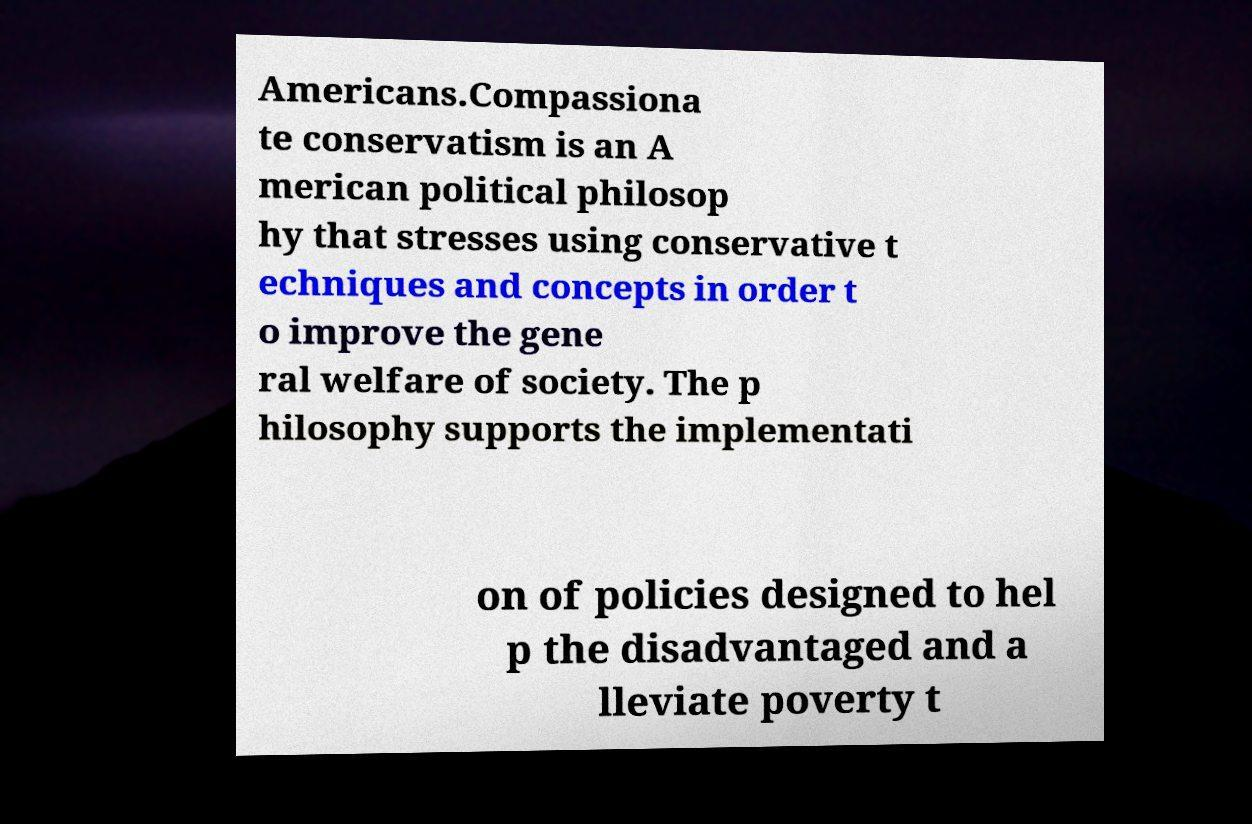For documentation purposes, I need the text within this image transcribed. Could you provide that? Americans.Compassiona te conservatism is an A merican political philosop hy that stresses using conservative t echniques and concepts in order t o improve the gene ral welfare of society. The p hilosophy supports the implementati on of policies designed to hel p the disadvantaged and a lleviate poverty t 